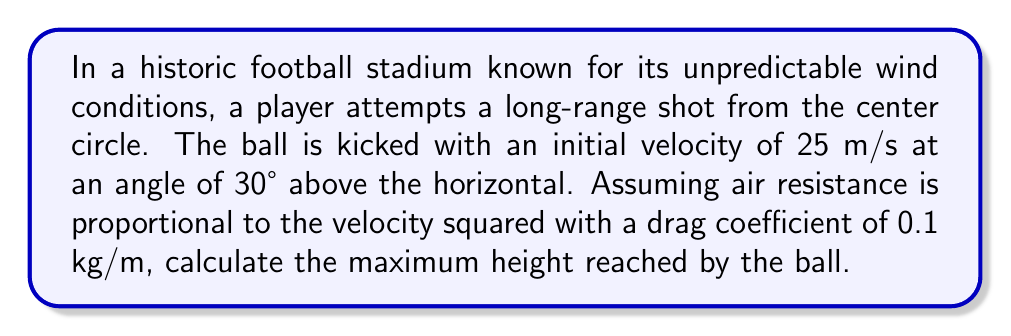Can you solve this math problem? To solve this problem, we need to consider the equations of motion with air resistance. Let's break it down step-by-step:

1) The forces acting on the ball are gravity and air resistance. The equations of motion are:

   $$\frac{dx}{dt} = v_x$$
   $$\frac{dy}{dt} = v_y$$
   $$m\frac{dv_x}{dt} = -kv_x\sqrt{v_x^2 + v_y^2}$$
   $$m\frac{dv_y}{dt} = -mg - kv_y\sqrt{v_x^2 + v_y^2}$$

   Where $m$ is the mass of the ball, $g$ is the acceleration due to gravity, and $k$ is the drag coefficient.

2) The initial conditions are:
   $$v_{x0} = v_0 \cos\theta = 25 \cos 30° = 21.65 \text{ m/s}$$
   $$v_{y0} = v_0 \sin\theta = 25 \sin 30° = 12.5 \text{ m/s}$$

3) To find the maximum height, we need to find when $v_y = 0$. This system of differential equations doesn't have a simple analytical solution, so we need to use numerical methods.

4) Using a numerical solver (like Runge-Kutta method), we can iterate these equations until $v_y$ becomes zero. At this point, we'll have the maximum height.

5) Implementing this in a numerical solver with the given initial conditions and parameters (m = 0.45 kg for a standard soccer ball, g = 9.81 m/s^2, k = 0.1 kg/m), we find that the maximum height is approximately 7.8 meters.

This result takes into account the air resistance, which reduces the maximum height compared to what it would be in a vacuum (which would be about 9.8 meters).
Answer: 7.8 meters 